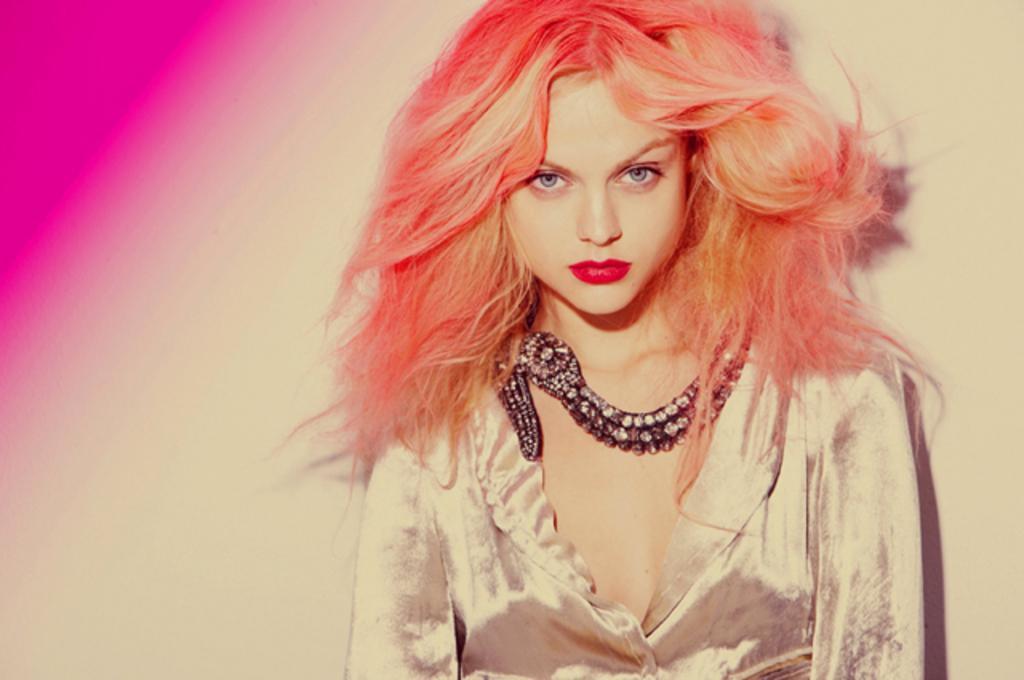Could you give a brief overview of what you see in this image? In this image, in the middle, we can see a woman with orange color hair. In the left corner, we can also see pink color. 